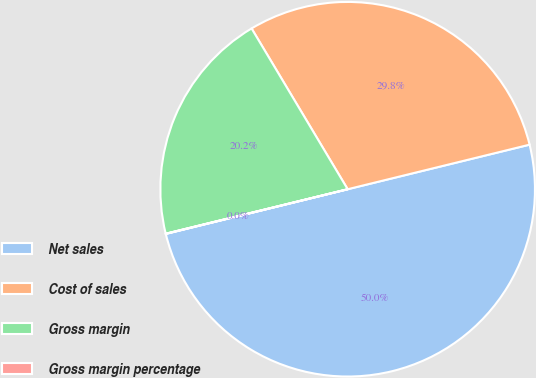<chart> <loc_0><loc_0><loc_500><loc_500><pie_chart><fcel>Net sales<fcel>Cost of sales<fcel>Gross margin<fcel>Gross margin percentage<nl><fcel>49.99%<fcel>29.75%<fcel>20.24%<fcel>0.02%<nl></chart> 